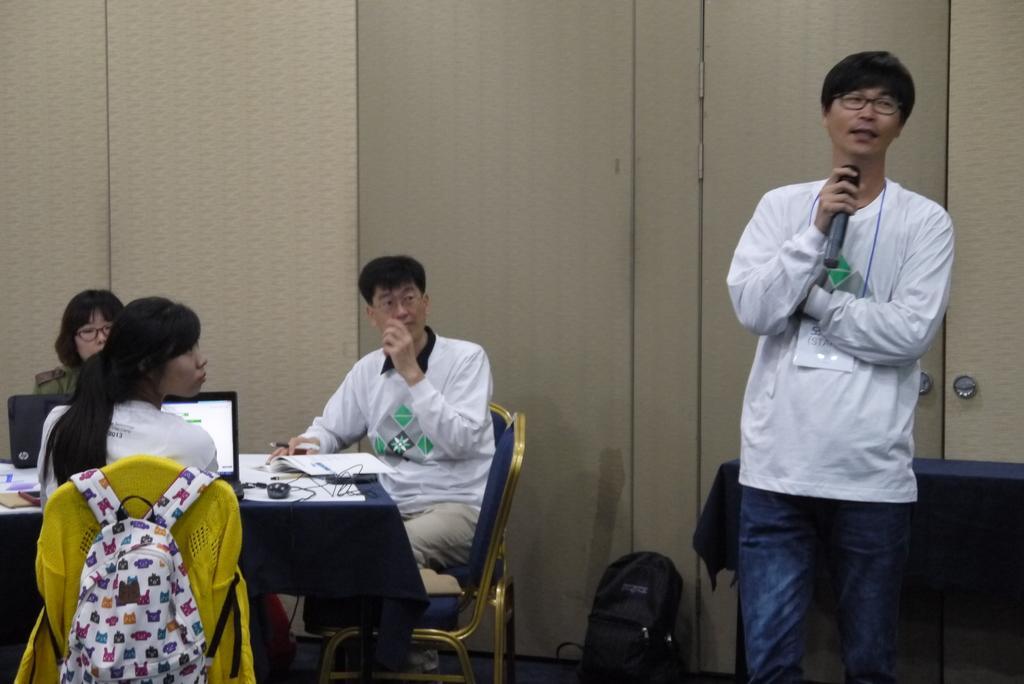How would you summarize this image in a sentence or two? In this image i can see group of persons sitting and at the right side of the image there is a person wearing white color dress standing and holding microphone. 